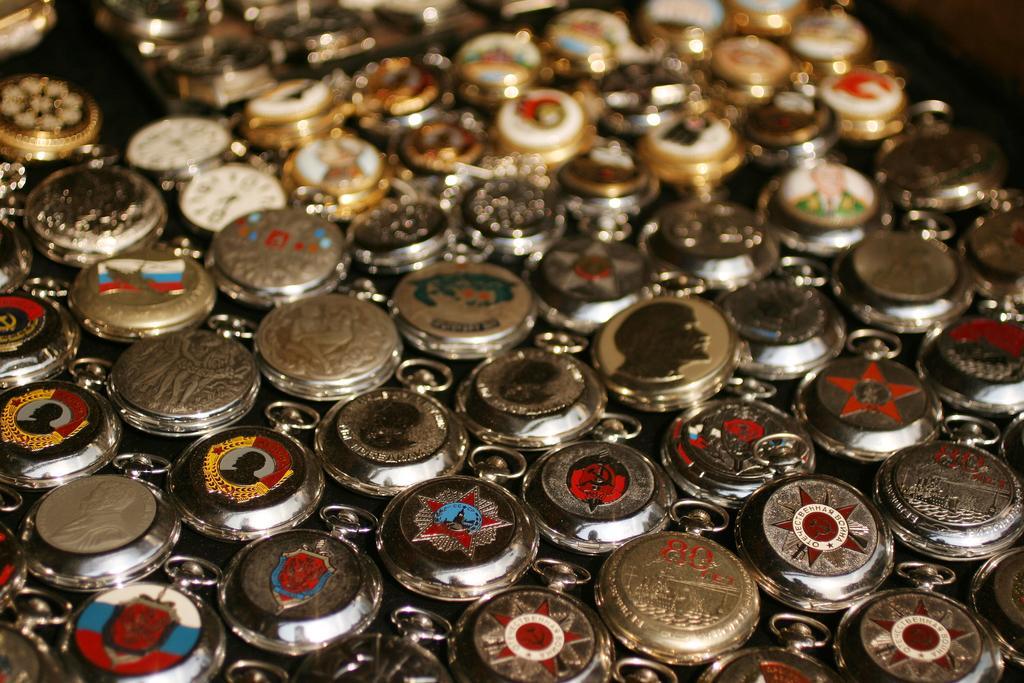Could you give a brief overview of what you see in this image? In this image in the middle, there are different types of coins. 